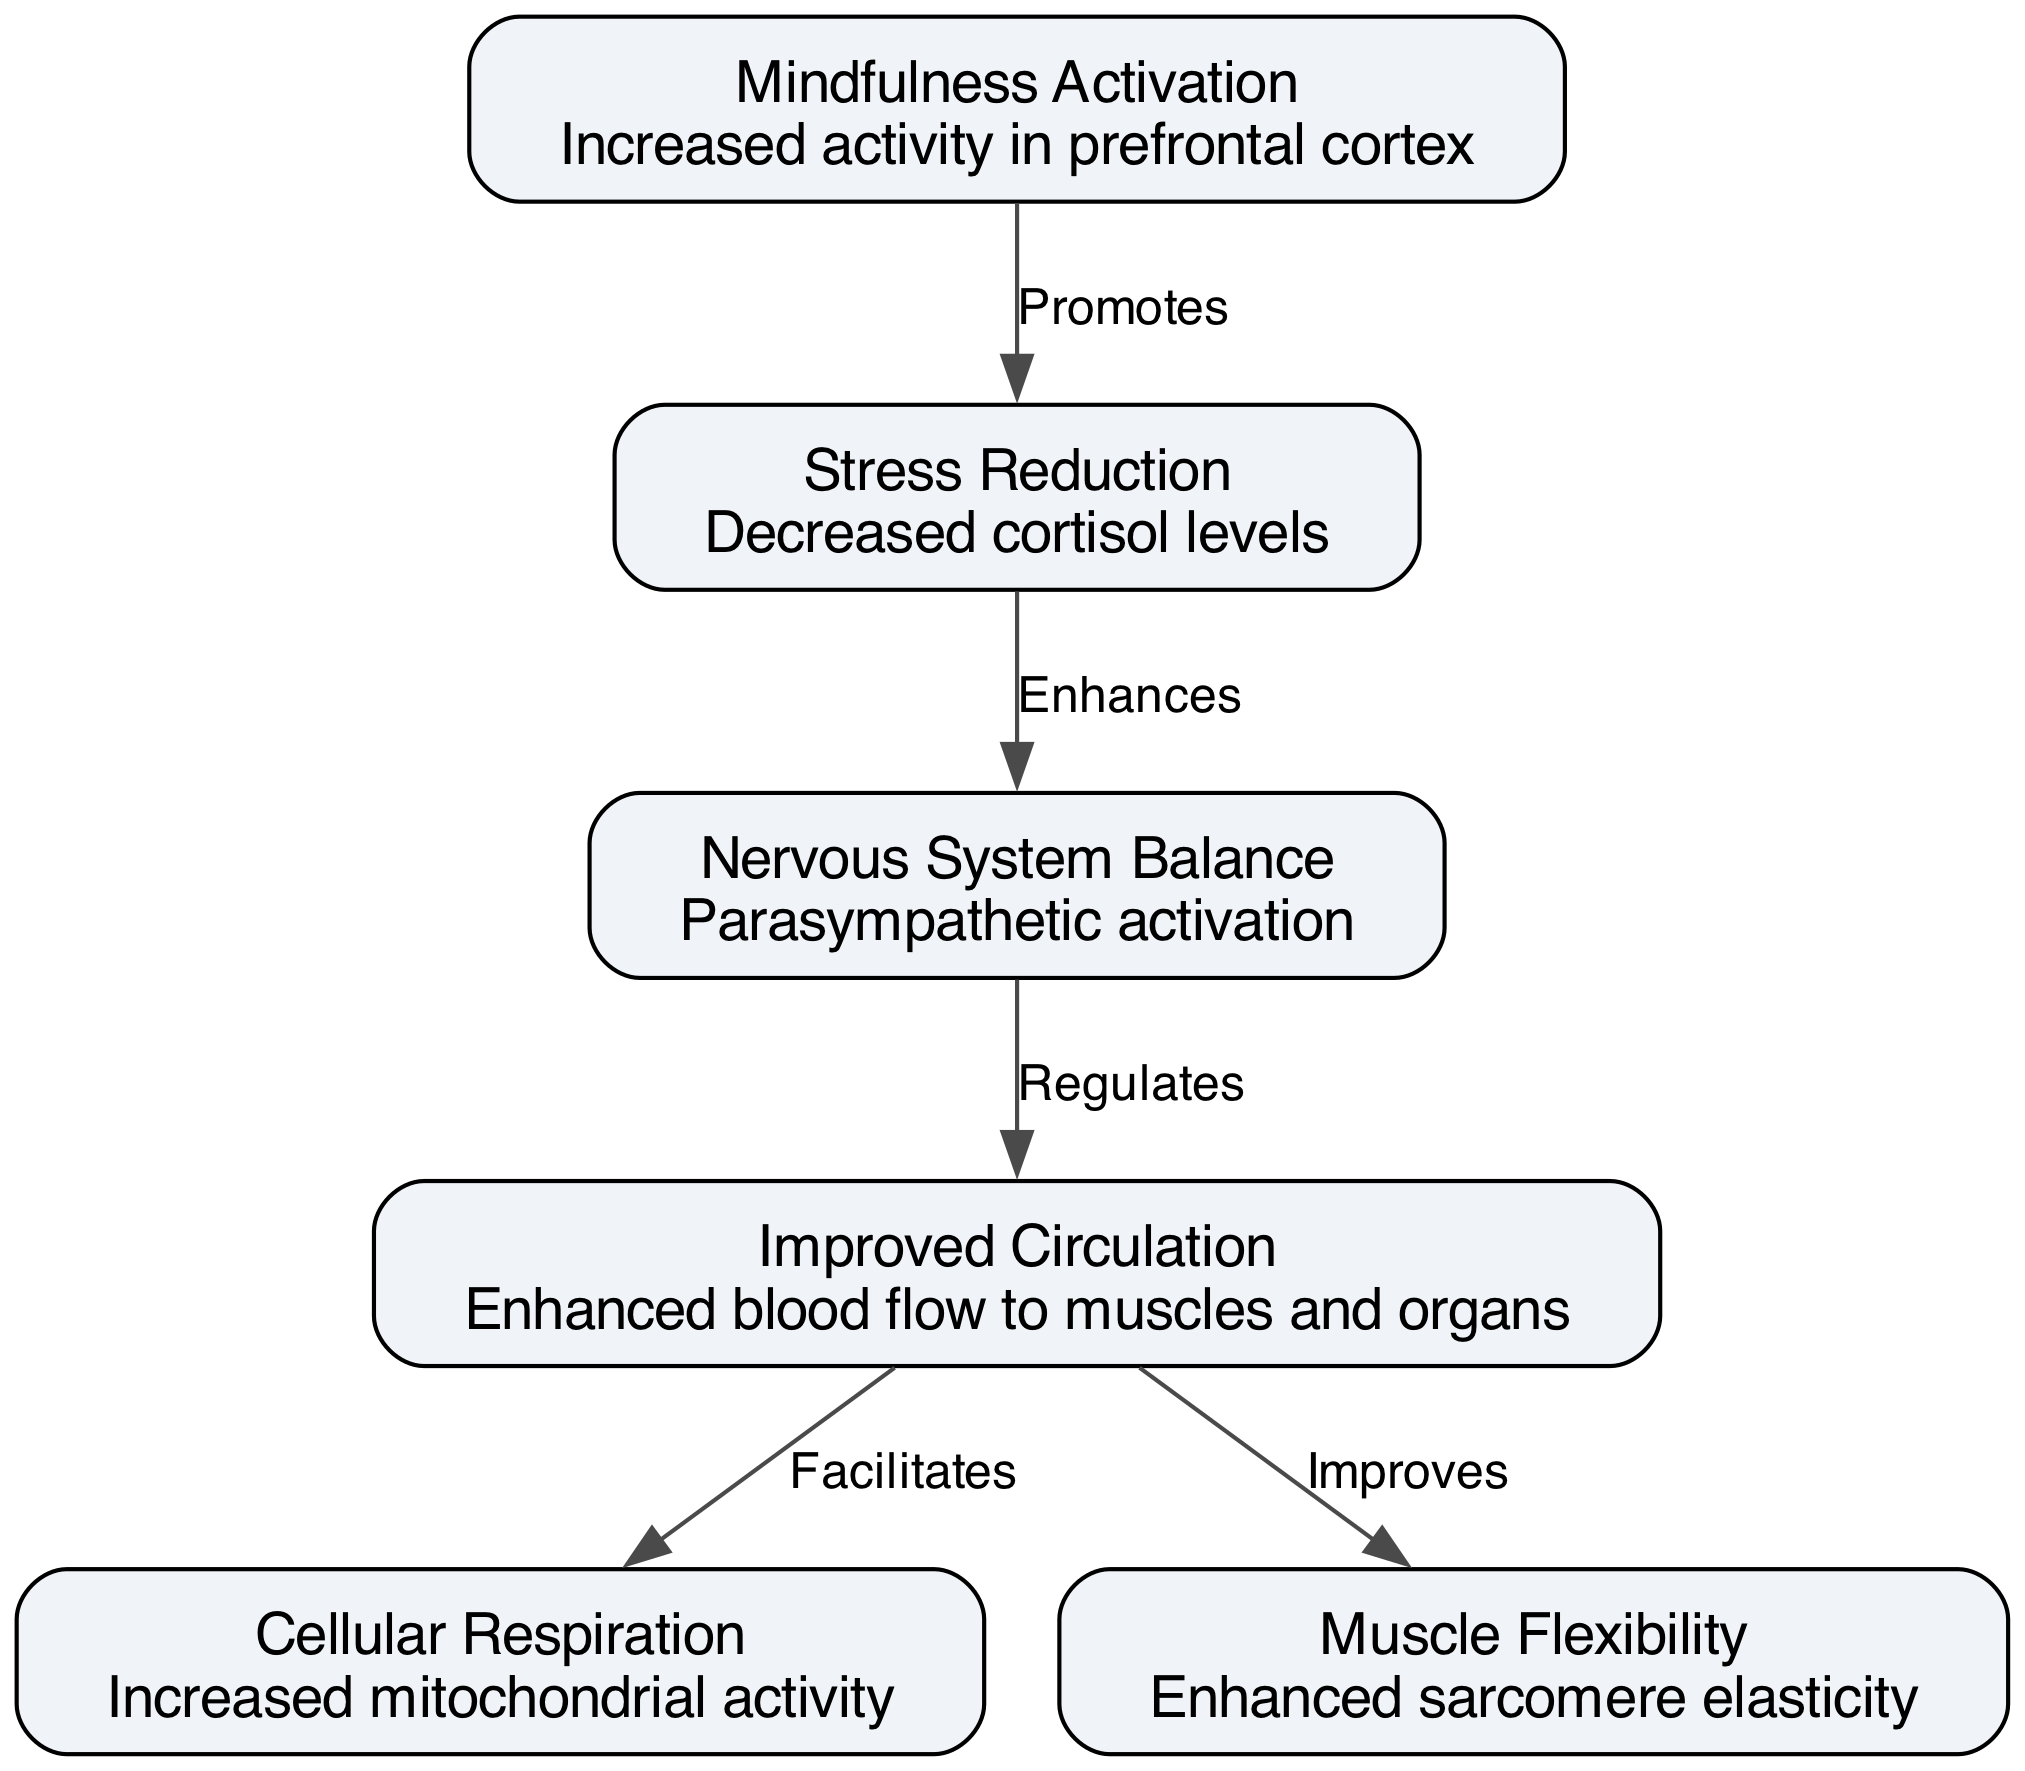What is the total number of nodes in the diagram? There are 6 nodes listed in the data under the 'nodes' key: Mindfulness Activation, Stress Reduction, Improved Circulation, Cellular Respiration, Muscle Flexibility, and Nervous System Balance.
Answer: 6 Which node is associated with decreased cortisol levels? The node that describes decreased cortisol levels is Stress Reduction, as indicated in the description provided.
Answer: Stress Reduction What relationship exists between Mindfulness Activation and Stress Reduction? The edge connects Mindfulness Activation to Stress Reduction with the label "Promotes," indicating a promoting relationship between the two nodes.
Answer: Promotes Which node enhances blood flow to muscles and organs? Improved Circulation is the node that mentions enhanced blood flow to muscles and organs in its description.
Answer: Improved Circulation What is the direct effect of Improved Circulation on Cellular Respiration? Improved Circulation facilitates Cellular Respiration as noted in the edge connecting the two nodes in the diagram.
Answer: Facilitates How does the Nervous System Balance affect Improved Circulation? Nervous System Balance regulates Improved Circulation, as indicated by the edge labeled "Regulates" between the two nodes, showing a regulatory influence.
Answer: Regulates What physiological change results in enhanced sarcomere elasticity? Muscle Flexibility is the physiological change that results in enhanced sarcomere elasticity, as mentioned in its description.
Answer: Muscle Flexibility Which node shows increased activity in the prefrontal cortex? Mindfulness Activation is the node that is associated with increased activity in the prefrontal cortex according to its description.
Answer: Mindfulness Activation 